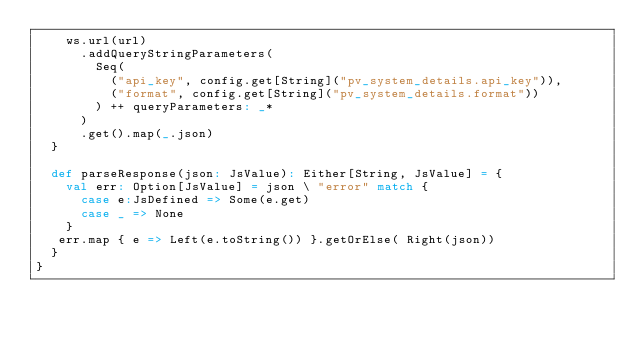<code> <loc_0><loc_0><loc_500><loc_500><_Scala_>    ws.url(url)
      .addQueryStringParameters(
        Seq(
          ("api_key", config.get[String]("pv_system_details.api_key")),
          ("format", config.get[String]("pv_system_details.format"))
        ) ++ queryParameters: _*
      )
      .get().map(_.json)
  }

  def parseResponse(json: JsValue): Either[String, JsValue] = {
    val err: Option[JsValue] = json \ "error" match {
      case e:JsDefined => Some(e.get)
      case _ => None
    }
   err.map { e => Left(e.toString()) }.getOrElse( Right(json))
  }
}


</code> 